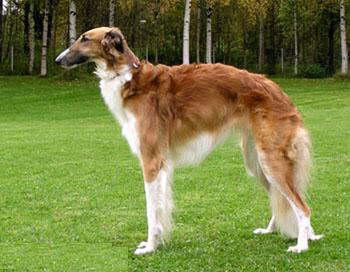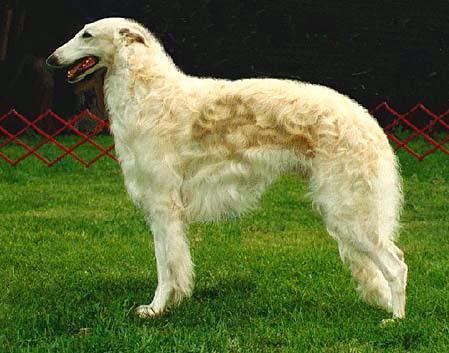The first image is the image on the left, the second image is the image on the right. For the images shown, is this caption "The dog in the image on the left is facing left and the dog in the image on the right is facing right." true? Answer yes or no. No. 